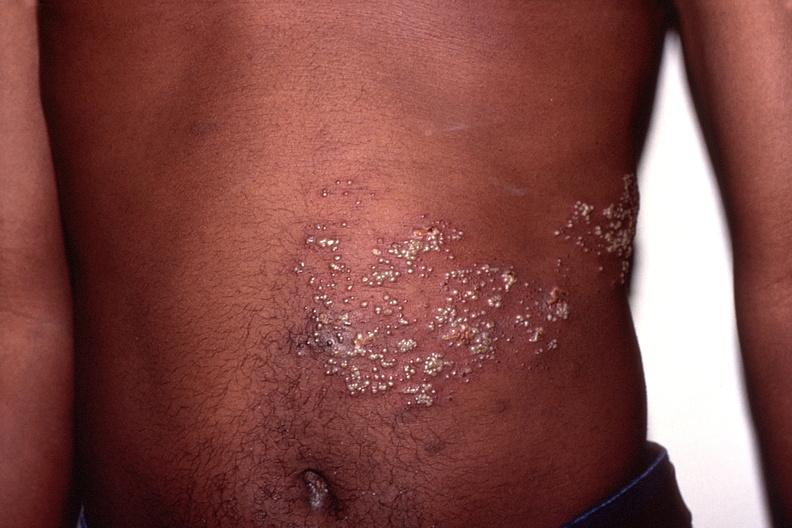what does this image show?
Answer the question using a single word or phrase. Herpes zoster 